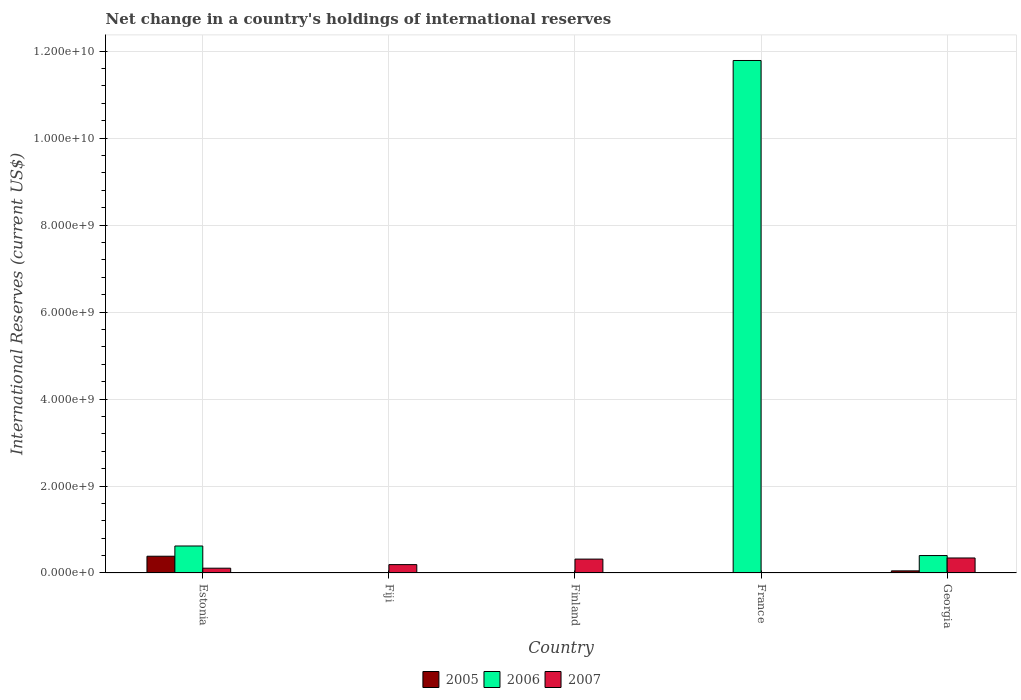How many different coloured bars are there?
Offer a terse response. 3. Are the number of bars on each tick of the X-axis equal?
Keep it short and to the point. No. How many bars are there on the 5th tick from the right?
Provide a succinct answer. 3. What is the label of the 5th group of bars from the left?
Keep it short and to the point. Georgia. In how many cases, is the number of bars for a given country not equal to the number of legend labels?
Make the answer very short. 3. What is the international reserves in 2007 in Estonia?
Your answer should be compact. 1.10e+08. Across all countries, what is the maximum international reserves in 2005?
Offer a very short reply. 3.86e+08. In which country was the international reserves in 2006 maximum?
Keep it short and to the point. France. What is the total international reserves in 2006 in the graph?
Your answer should be compact. 1.28e+1. What is the difference between the international reserves in 2006 in Estonia and that in France?
Provide a succinct answer. -1.12e+1. What is the difference between the international reserves in 2007 in Georgia and the international reserves in 2005 in Finland?
Your answer should be very brief. 3.45e+08. What is the average international reserves in 2005 per country?
Your answer should be compact. 8.69e+07. What is the difference between the international reserves of/in 2006 and international reserves of/in 2005 in Estonia?
Provide a short and direct response. 2.35e+08. In how many countries, is the international reserves in 2005 greater than 1600000000 US$?
Offer a very short reply. 0. What is the ratio of the international reserves in 2007 in Estonia to that in Georgia?
Your answer should be compact. 0.32. What is the difference between the highest and the second highest international reserves in 2006?
Provide a short and direct response. -2.20e+08. What is the difference between the highest and the lowest international reserves in 2005?
Ensure brevity in your answer.  3.86e+08. Is the sum of the international reserves in 2007 in Finland and Georgia greater than the maximum international reserves in 2005 across all countries?
Offer a terse response. Yes. How many bars are there?
Keep it short and to the point. 9. Are all the bars in the graph horizontal?
Give a very brief answer. No. How many countries are there in the graph?
Your answer should be very brief. 5. What is the difference between two consecutive major ticks on the Y-axis?
Make the answer very short. 2.00e+09. Does the graph contain any zero values?
Keep it short and to the point. Yes. How many legend labels are there?
Ensure brevity in your answer.  3. What is the title of the graph?
Your answer should be very brief. Net change in a country's holdings of international reserves. Does "1997" appear as one of the legend labels in the graph?
Offer a terse response. No. What is the label or title of the X-axis?
Your answer should be compact. Country. What is the label or title of the Y-axis?
Give a very brief answer. International Reserves (current US$). What is the International Reserves (current US$) in 2005 in Estonia?
Offer a very short reply. 3.86e+08. What is the International Reserves (current US$) of 2006 in Estonia?
Offer a terse response. 6.21e+08. What is the International Reserves (current US$) of 2007 in Estonia?
Provide a succinct answer. 1.10e+08. What is the International Reserves (current US$) of 2007 in Fiji?
Your answer should be compact. 1.93e+08. What is the International Reserves (current US$) in 2005 in Finland?
Your answer should be very brief. 0. What is the International Reserves (current US$) in 2006 in Finland?
Your answer should be very brief. 0. What is the International Reserves (current US$) of 2007 in Finland?
Keep it short and to the point. 3.20e+08. What is the International Reserves (current US$) of 2005 in France?
Offer a terse response. 0. What is the International Reserves (current US$) of 2006 in France?
Provide a short and direct response. 1.18e+1. What is the International Reserves (current US$) of 2005 in Georgia?
Ensure brevity in your answer.  4.88e+07. What is the International Reserves (current US$) of 2006 in Georgia?
Make the answer very short. 4.01e+08. What is the International Reserves (current US$) of 2007 in Georgia?
Ensure brevity in your answer.  3.45e+08. Across all countries, what is the maximum International Reserves (current US$) of 2005?
Your answer should be very brief. 3.86e+08. Across all countries, what is the maximum International Reserves (current US$) of 2006?
Keep it short and to the point. 1.18e+1. Across all countries, what is the maximum International Reserves (current US$) in 2007?
Provide a short and direct response. 3.45e+08. Across all countries, what is the minimum International Reserves (current US$) of 2006?
Provide a short and direct response. 0. What is the total International Reserves (current US$) of 2005 in the graph?
Provide a short and direct response. 4.34e+08. What is the total International Reserves (current US$) in 2006 in the graph?
Offer a very short reply. 1.28e+1. What is the total International Reserves (current US$) of 2007 in the graph?
Your response must be concise. 9.68e+08. What is the difference between the International Reserves (current US$) in 2007 in Estonia and that in Fiji?
Your response must be concise. -8.23e+07. What is the difference between the International Reserves (current US$) of 2007 in Estonia and that in Finland?
Your response must be concise. -2.09e+08. What is the difference between the International Reserves (current US$) in 2006 in Estonia and that in France?
Your answer should be very brief. -1.12e+1. What is the difference between the International Reserves (current US$) in 2005 in Estonia and that in Georgia?
Give a very brief answer. 3.37e+08. What is the difference between the International Reserves (current US$) of 2006 in Estonia and that in Georgia?
Make the answer very short. 2.20e+08. What is the difference between the International Reserves (current US$) of 2007 in Estonia and that in Georgia?
Give a very brief answer. -2.35e+08. What is the difference between the International Reserves (current US$) in 2007 in Fiji and that in Finland?
Provide a succinct answer. -1.27e+08. What is the difference between the International Reserves (current US$) of 2007 in Fiji and that in Georgia?
Your answer should be very brief. -1.53e+08. What is the difference between the International Reserves (current US$) of 2007 in Finland and that in Georgia?
Make the answer very short. -2.59e+07. What is the difference between the International Reserves (current US$) of 2006 in France and that in Georgia?
Provide a succinct answer. 1.14e+1. What is the difference between the International Reserves (current US$) of 2005 in Estonia and the International Reserves (current US$) of 2007 in Fiji?
Offer a very short reply. 1.93e+08. What is the difference between the International Reserves (current US$) in 2006 in Estonia and the International Reserves (current US$) in 2007 in Fiji?
Your answer should be very brief. 4.28e+08. What is the difference between the International Reserves (current US$) of 2005 in Estonia and the International Reserves (current US$) of 2007 in Finland?
Your answer should be very brief. 6.60e+07. What is the difference between the International Reserves (current US$) of 2006 in Estonia and the International Reserves (current US$) of 2007 in Finland?
Provide a short and direct response. 3.01e+08. What is the difference between the International Reserves (current US$) in 2005 in Estonia and the International Reserves (current US$) in 2006 in France?
Your answer should be very brief. -1.14e+1. What is the difference between the International Reserves (current US$) in 2005 in Estonia and the International Reserves (current US$) in 2006 in Georgia?
Offer a terse response. -1.56e+07. What is the difference between the International Reserves (current US$) of 2005 in Estonia and the International Reserves (current US$) of 2007 in Georgia?
Offer a terse response. 4.01e+07. What is the difference between the International Reserves (current US$) of 2006 in Estonia and the International Reserves (current US$) of 2007 in Georgia?
Provide a succinct answer. 2.75e+08. What is the difference between the International Reserves (current US$) in 2006 in France and the International Reserves (current US$) in 2007 in Georgia?
Give a very brief answer. 1.14e+1. What is the average International Reserves (current US$) in 2005 per country?
Give a very brief answer. 8.69e+07. What is the average International Reserves (current US$) of 2006 per country?
Offer a very short reply. 2.56e+09. What is the average International Reserves (current US$) of 2007 per country?
Your answer should be very brief. 1.94e+08. What is the difference between the International Reserves (current US$) in 2005 and International Reserves (current US$) in 2006 in Estonia?
Provide a short and direct response. -2.35e+08. What is the difference between the International Reserves (current US$) in 2005 and International Reserves (current US$) in 2007 in Estonia?
Ensure brevity in your answer.  2.75e+08. What is the difference between the International Reserves (current US$) in 2006 and International Reserves (current US$) in 2007 in Estonia?
Your response must be concise. 5.10e+08. What is the difference between the International Reserves (current US$) of 2005 and International Reserves (current US$) of 2006 in Georgia?
Make the answer very short. -3.52e+08. What is the difference between the International Reserves (current US$) in 2005 and International Reserves (current US$) in 2007 in Georgia?
Your answer should be compact. -2.97e+08. What is the difference between the International Reserves (current US$) of 2006 and International Reserves (current US$) of 2007 in Georgia?
Your answer should be compact. 5.57e+07. What is the ratio of the International Reserves (current US$) in 2007 in Estonia to that in Fiji?
Offer a very short reply. 0.57. What is the ratio of the International Reserves (current US$) in 2007 in Estonia to that in Finland?
Provide a short and direct response. 0.34. What is the ratio of the International Reserves (current US$) in 2006 in Estonia to that in France?
Your response must be concise. 0.05. What is the ratio of the International Reserves (current US$) in 2005 in Estonia to that in Georgia?
Make the answer very short. 7.9. What is the ratio of the International Reserves (current US$) of 2006 in Estonia to that in Georgia?
Make the answer very short. 1.55. What is the ratio of the International Reserves (current US$) of 2007 in Estonia to that in Georgia?
Ensure brevity in your answer.  0.32. What is the ratio of the International Reserves (current US$) in 2007 in Fiji to that in Finland?
Your answer should be compact. 0.6. What is the ratio of the International Reserves (current US$) in 2007 in Fiji to that in Georgia?
Give a very brief answer. 0.56. What is the ratio of the International Reserves (current US$) of 2007 in Finland to that in Georgia?
Keep it short and to the point. 0.93. What is the ratio of the International Reserves (current US$) in 2006 in France to that in Georgia?
Your answer should be very brief. 29.38. What is the difference between the highest and the second highest International Reserves (current US$) in 2006?
Your answer should be very brief. 1.12e+1. What is the difference between the highest and the second highest International Reserves (current US$) of 2007?
Provide a short and direct response. 2.59e+07. What is the difference between the highest and the lowest International Reserves (current US$) in 2005?
Provide a succinct answer. 3.86e+08. What is the difference between the highest and the lowest International Reserves (current US$) of 2006?
Your response must be concise. 1.18e+1. What is the difference between the highest and the lowest International Reserves (current US$) in 2007?
Offer a very short reply. 3.45e+08. 